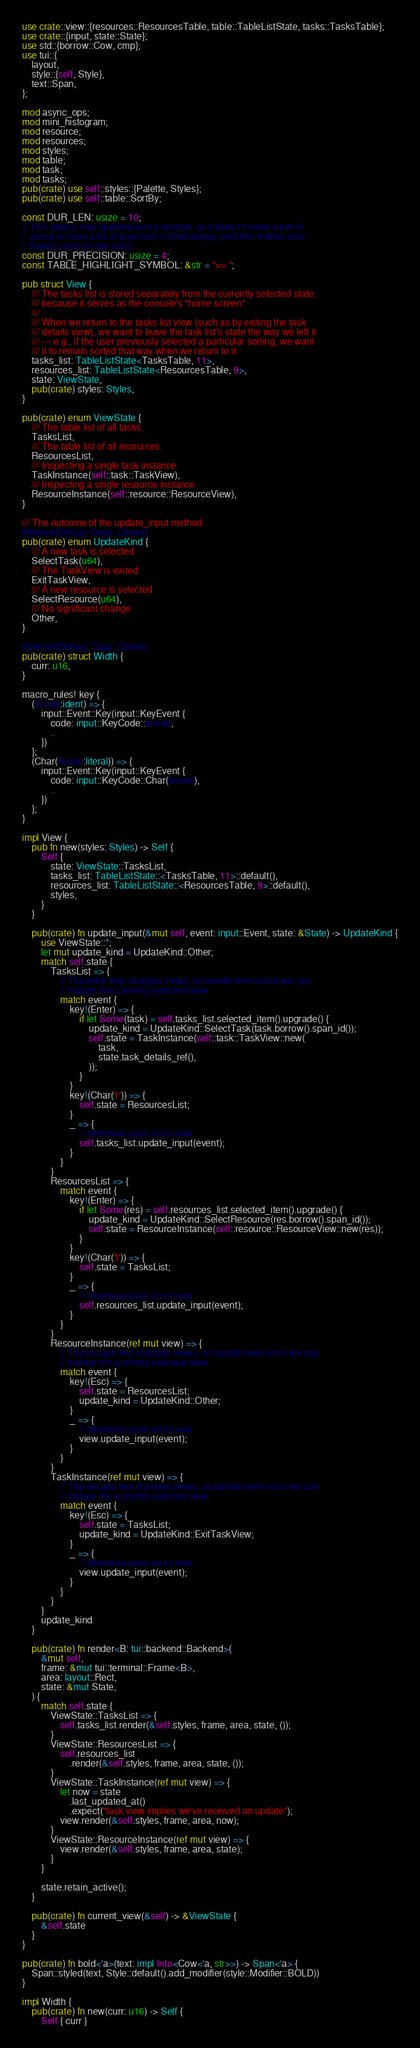Convert code to text. <code><loc_0><loc_0><loc_500><loc_500><_Rust_>use crate::view::{resources::ResourcesTable, table::TableListState, tasks::TasksTable};
use crate::{input, state::State};
use std::{borrow::Cow, cmp};
use tui::{
    layout,
    style::{self, Style},
    text::Span,
};

mod async_ops;
mod mini_histogram;
mod resource;
mod resources;
mod styles;
mod table;
mod task;
mod tasks;
pub(crate) use self::styles::{Palette, Styles};
pub(crate) use self::table::SortBy;

const DUR_LEN: usize = 10;
// This data is only updated every second, so it doesn't make a ton of
// sense to have a lot of precision in timestamps (and this makes sure
// there's room for the unit!)
const DUR_PRECISION: usize = 4;
const TABLE_HIGHLIGHT_SYMBOL: &str = ">> ";

pub struct View {
    /// The tasks list is stored separately from the currently selected state,
    /// because it serves as the console's "home screen".
    ///
    /// When we return to the tasks list view (such as by exiting the task
    /// details view), we want to leave the task list's state the way we left it
    /// --- e.g., if the user previously selected a particular sorting, we want
    /// it to remain sorted that way when we return to it.
    tasks_list: TableListState<TasksTable, 11>,
    resources_list: TableListState<ResourcesTable, 9>,
    state: ViewState,
    pub(crate) styles: Styles,
}

pub(crate) enum ViewState {
    /// The table list of all tasks.
    TasksList,
    /// The table list of all resources.
    ResourcesList,
    /// Inspecting a single task instance.
    TaskInstance(self::task::TaskView),
    /// Inspecting a single resource instance.
    ResourceInstance(self::resource::ResourceView),
}

/// The outcome of the update_input method
#[derive(Debug, Copy, Clone)]
pub(crate) enum UpdateKind {
    /// A new task is selected
    SelectTask(u64),
    /// The TaskView is exited
    ExitTaskView,
    /// A new resource is selected
    SelectResource(u64),
    /// No significant change
    Other,
}

#[derive(Debug, Copy, Clone)]
pub(crate) struct Width {
    curr: u16,
}

macro_rules! key {
    ($code:ident) => {
        input::Event::Key(input::KeyEvent {
            code: input::KeyCode::$code,
            ..
        })
    };
    (Char($code:literal)) => {
        input::Event::Key(input::KeyEvent {
            code: input::KeyCode::Char($code),
            ..
        })
    };
}

impl View {
    pub fn new(styles: Styles) -> Self {
        Self {
            state: ViewState::TasksList,
            tasks_list: TableListState::<TasksTable, 11>::default(),
            resources_list: TableListState::<ResourcesTable, 9>::default(),
            styles,
        }
    }

    pub(crate) fn update_input(&mut self, event: input::Event, state: &State) -> UpdateKind {
        use ViewState::*;
        let mut update_kind = UpdateKind::Other;
        match self.state {
            TasksList => {
                // The enter key changes views, so handle here since we can
                // mutate the currently selected view.
                match event {
                    key!(Enter) => {
                        if let Some(task) = self.tasks_list.selected_item().upgrade() {
                            update_kind = UpdateKind::SelectTask(task.borrow().span_id());
                            self.state = TaskInstance(self::task::TaskView::new(
                                task,
                                state.task_details_ref(),
                            ));
                        }
                    }
                    key!(Char('r')) => {
                        self.state = ResourcesList;
                    }
                    _ => {
                        // otherwise pass on to view
                        self.tasks_list.update_input(event);
                    }
                }
            }
            ResourcesList => {
                match event {
                    key!(Enter) => {
                        if let Some(res) = self.resources_list.selected_item().upgrade() {
                            update_kind = UpdateKind::SelectResource(res.borrow().span_id());
                            self.state = ResourceInstance(self::resource::ResourceView::new(res));
                        }
                    }
                    key!(Char('t')) => {
                        self.state = TasksList;
                    }
                    _ => {
                        // otherwise pass on to view
                        self.resources_list.update_input(event);
                    }
                }
            }
            ResourceInstance(ref mut view) => {
                // The escape key changes views, so handle here since we can
                // mutate the currently selected view.
                match event {
                    key!(Esc) => {
                        self.state = ResourcesList;
                        update_kind = UpdateKind::Other;
                    }
                    _ => {
                        // otherwise pass on to view
                        view.update_input(event);
                    }
                }
            }
            TaskInstance(ref mut view) => {
                // The escape key changes views, so handle here since we can
                // mutate the currently selected view.
                match event {
                    key!(Esc) => {
                        self.state = TasksList;
                        update_kind = UpdateKind::ExitTaskView;
                    }
                    _ => {
                        // otherwise pass on to view
                        view.update_input(event);
                    }
                }
            }
        }
        update_kind
    }

    pub(crate) fn render<B: tui::backend::Backend>(
        &mut self,
        frame: &mut tui::terminal::Frame<B>,
        area: layout::Rect,
        state: &mut State,
    ) {
        match self.state {
            ViewState::TasksList => {
                self.tasks_list.render(&self.styles, frame, area, state, ());
            }
            ViewState::ResourcesList => {
                self.resources_list
                    .render(&self.styles, frame, area, state, ());
            }
            ViewState::TaskInstance(ref mut view) => {
                let now = state
                    .last_updated_at()
                    .expect("task view implies we've received an update");
                view.render(&self.styles, frame, area, now);
            }
            ViewState::ResourceInstance(ref mut view) => {
                view.render(&self.styles, frame, area, state);
            }
        }

        state.retain_active();
    }

    pub(crate) fn current_view(&self) -> &ViewState {
        &self.state
    }
}

pub(crate) fn bold<'a>(text: impl Into<Cow<'a, str>>) -> Span<'a> {
    Span::styled(text, Style::default().add_modifier(style::Modifier::BOLD))
}

impl Width {
    pub(crate) fn new(curr: u16) -> Self {
        Self { curr }</code> 